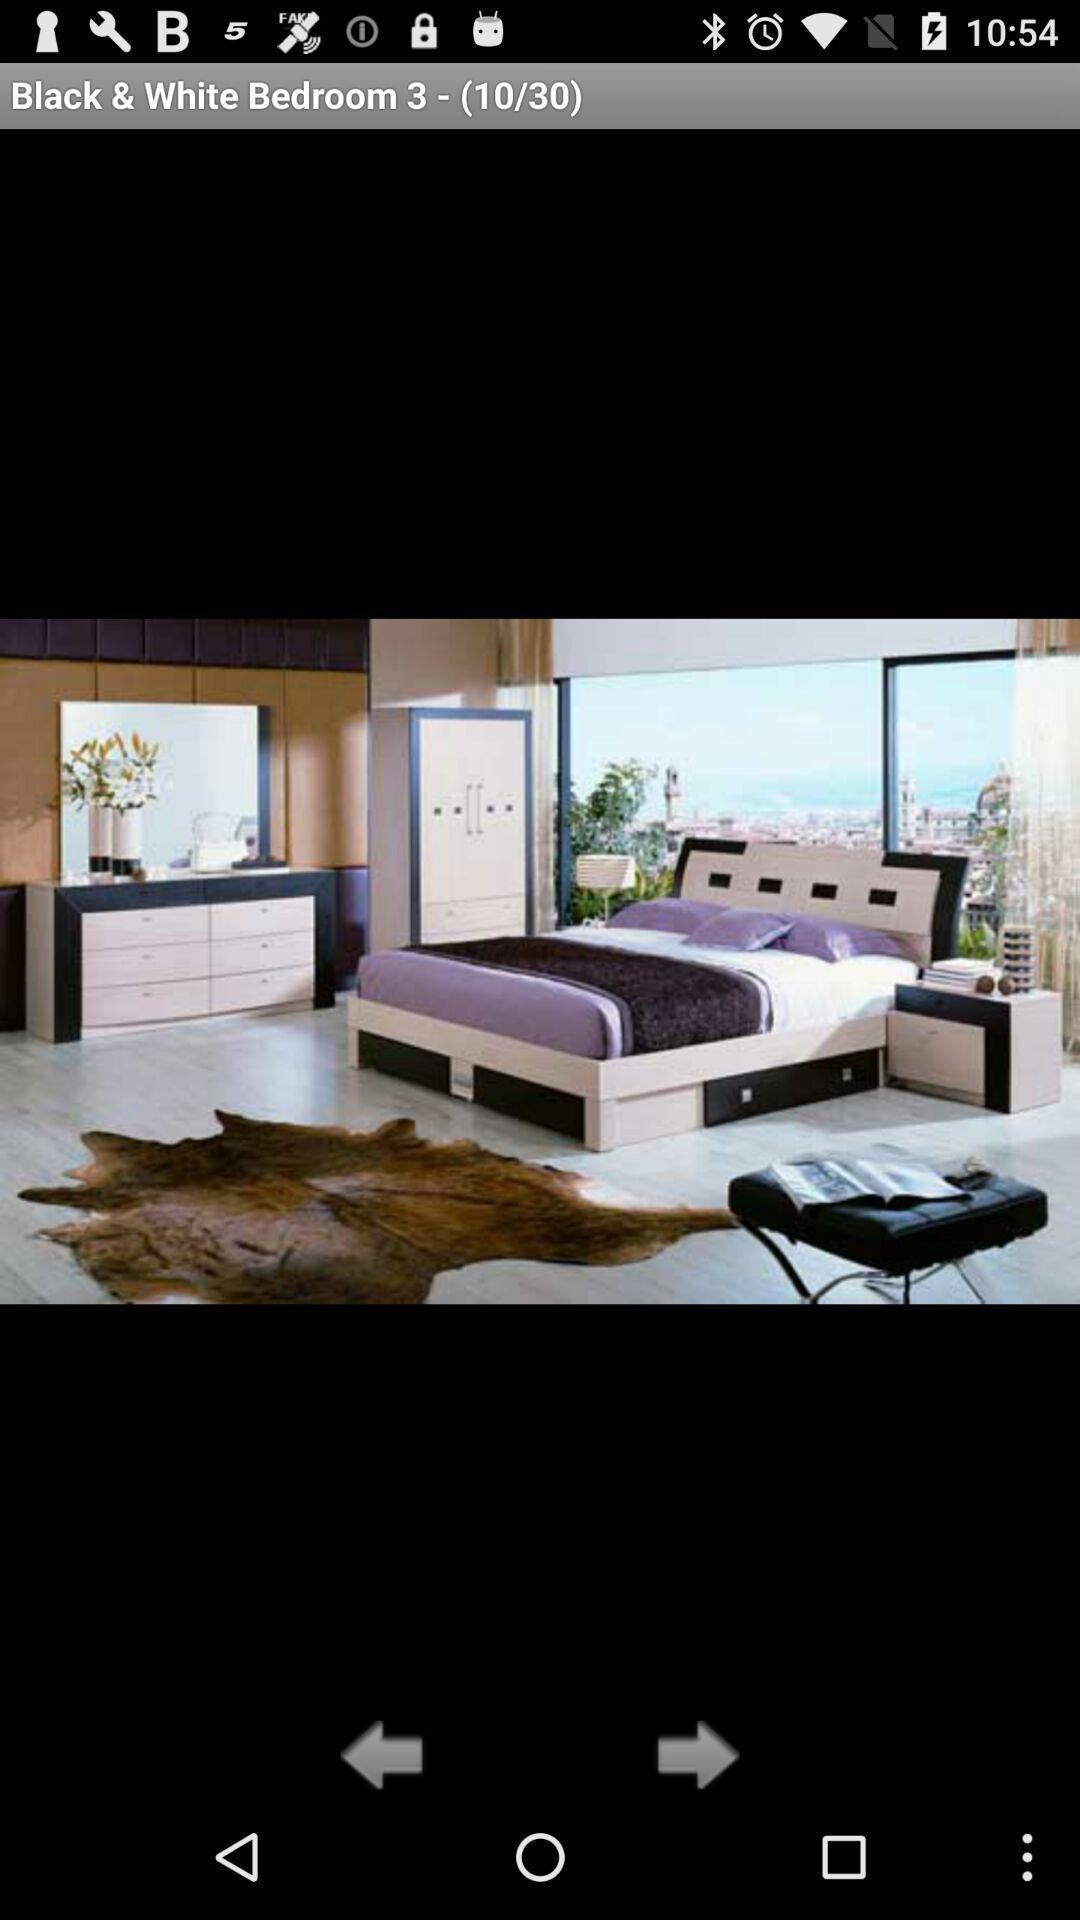What is the total number of images? The total number of images is 30. 